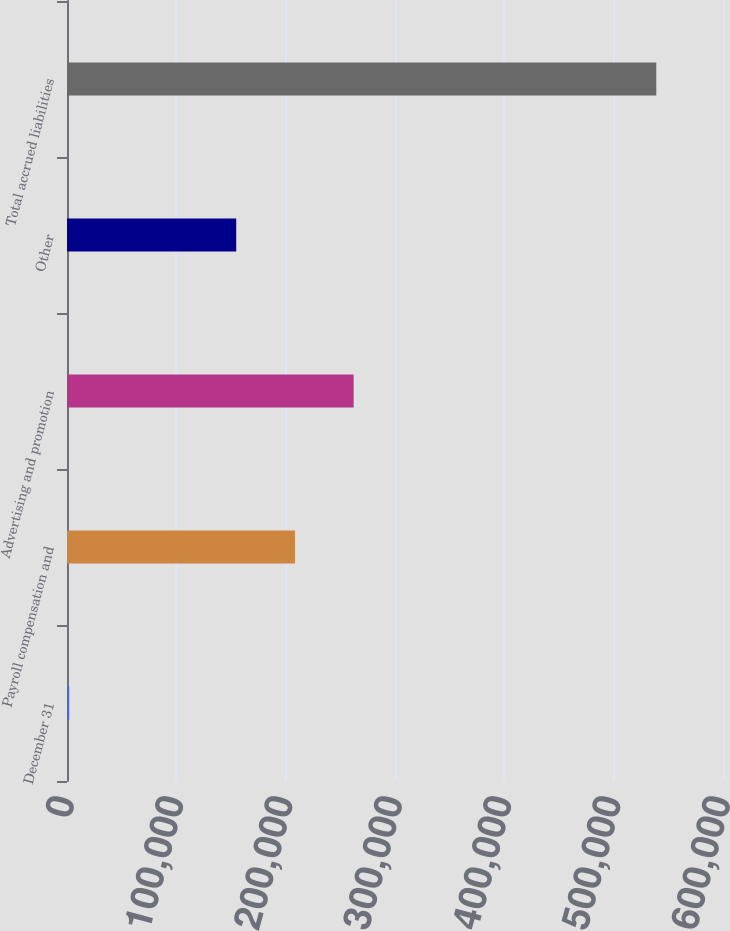Convert chart to OTSL. <chart><loc_0><loc_0><loc_500><loc_500><bar_chart><fcel>December 31<fcel>Payroll compensation and<fcel>Advertising and promotion<fcel>Other<fcel>Total accrued liabilities<nl><fcel>2007<fcel>208481<fcel>262179<fcel>154783<fcel>538986<nl></chart> 